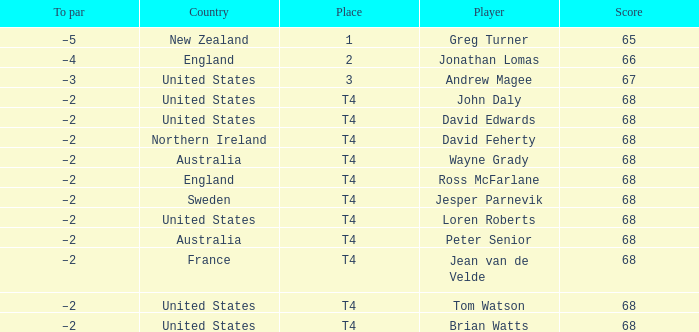Who has a To par of –2, and a Country of united states? John Daly, David Edwards, Loren Roberts, Tom Watson, Brian Watts. 